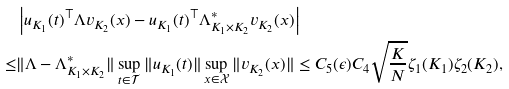<formula> <loc_0><loc_0><loc_500><loc_500>& \left | u _ { K _ { 1 } } ( t ) ^ { \top } \Lambda v _ { K _ { 2 } } ( x ) - u _ { K _ { 1 } } ( t ) ^ { \top } \Lambda ^ { * } _ { K _ { 1 } \times K _ { 2 } } v _ { K _ { 2 } } ( x ) \right | \\ \leq & \| \Lambda - \Lambda _ { K _ { 1 } \times K _ { 2 } } ^ { * } \| \sup _ { t \in \mathcal { T } } \| u _ { K _ { 1 } } ( t ) \| \sup _ { x \in \mathcal { X } } \| v _ { K _ { 2 } } ( x ) \| \leq C _ { 5 } ( \epsilon ) C _ { 4 } \sqrt { \frac { K } { N } } \zeta _ { 1 } ( K _ { 1 } ) \zeta _ { 2 } ( K _ { 2 } ) ,</formula> 